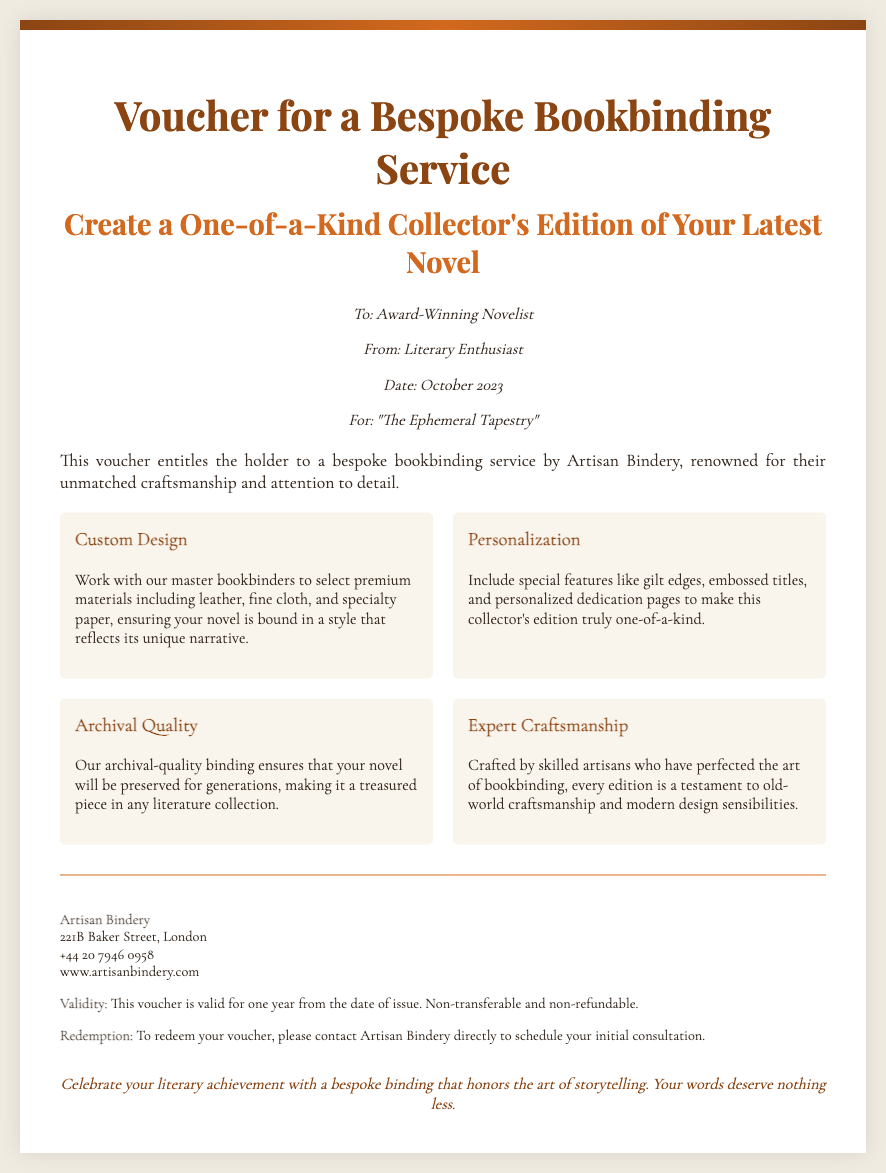What is the title of the novel for which this voucher is issued? The title is mentioned in the personalization section of the voucher.
Answer: The Ephemeral Tapestry Who is the issuer of the voucher? The issuer is indicated in the personalization section as well.
Answer: Literary Enthusiast What is the validity period of the voucher? The validity period is stated in the additional info section of the voucher.
Answer: One year What is the phone number for Artisan Bindery? The phone number is listed in the additional info section of the voucher.
Answer: +44 20 7946 0958 What type of service does this voucher provide? The type of service is described in the description section of the voucher.
Answer: Bespoke bookbinding What feature can be added to personalize the collector's edition? This can be found in the personalization benefits section of the voucher.
Answer: Gilt edges How many benefits are listed in the voucher? The number of benefits can be counted in the benefits section of the voucher.
Answer: Four Who are the artisans that craft the editions? This is mentioned in the expert craftsmanship benefit of the voucher.
Answer: Skilled artisans Where is Artisan Bindery located? The location is provided in the additional info section of the voucher.
Answer: 221B Baker Street, London 